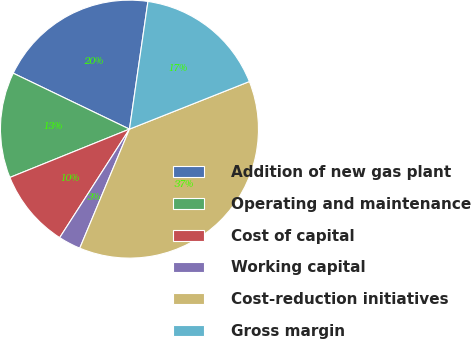Convert chart to OTSL. <chart><loc_0><loc_0><loc_500><loc_500><pie_chart><fcel>Addition of new gas plant<fcel>Operating and maintenance<fcel>Cost of capital<fcel>Working capital<fcel>Cost-reduction initiatives<fcel>Gross margin<nl><fcel>20.15%<fcel>13.25%<fcel>9.79%<fcel>2.8%<fcel>37.31%<fcel>16.7%<nl></chart> 